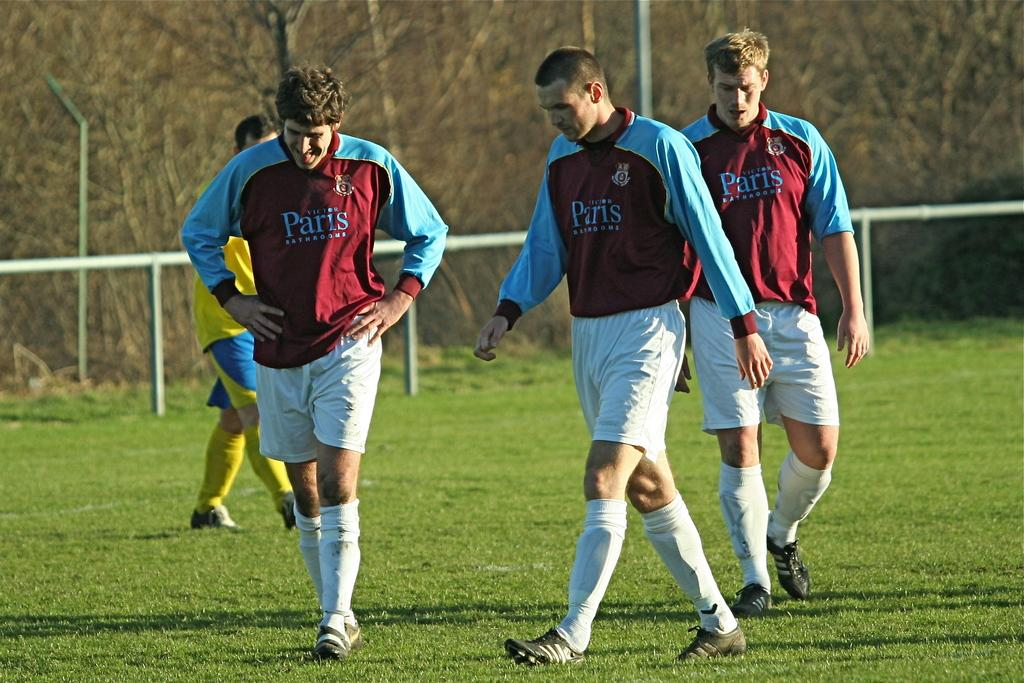What can be seen in the image? There are players in the image, and they are walking on a ground. What is visible in the background of the image? There is an iron railing and trees visible in the background of the image. How is the image quality? The image is blurred. What type of knowledge can be gained from the hydrant in the image? There is no hydrant present in the image, so no knowledge can be gained from it. 